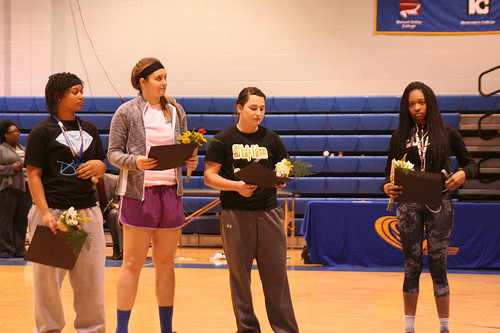<image>
Is the sock on the sock? No. The sock is not positioned on the sock. They may be near each other, but the sock is not supported by or resting on top of the sock. Is there a short woman under the big woman? No. The short woman is not positioned under the big woman. The vertical relationship between these objects is different. 